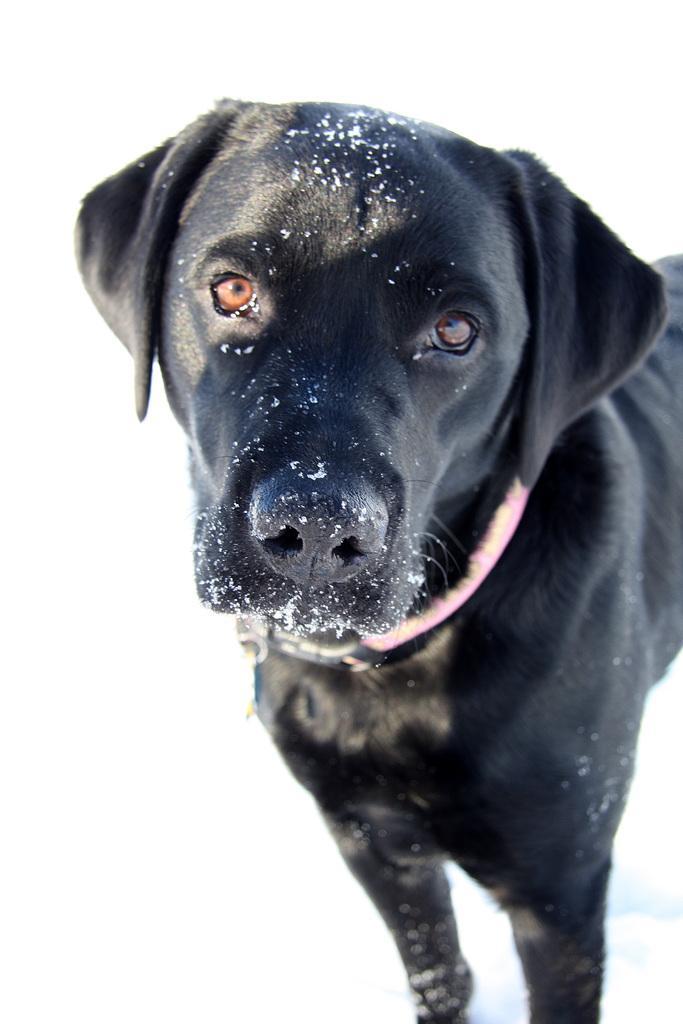How would you summarize this image in a sentence or two? In this image I can see the dog in black color and the background is in white color. 